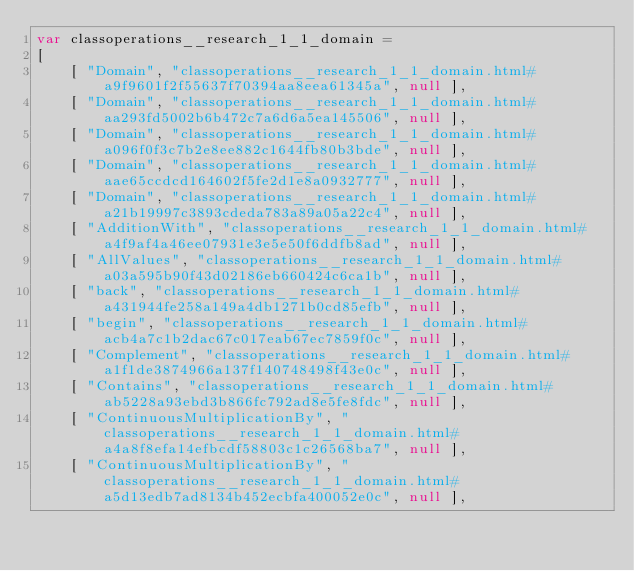<code> <loc_0><loc_0><loc_500><loc_500><_JavaScript_>var classoperations__research_1_1_domain =
[
    [ "Domain", "classoperations__research_1_1_domain.html#a9f9601f2f55637f70394aa8eea61345a", null ],
    [ "Domain", "classoperations__research_1_1_domain.html#aa293fd5002b6b472c7a6d6a5ea145506", null ],
    [ "Domain", "classoperations__research_1_1_domain.html#a096f0f3c7b2e8ee882c1644fb80b3bde", null ],
    [ "Domain", "classoperations__research_1_1_domain.html#aae65ccdcd164602f5fe2d1e8a0932777", null ],
    [ "Domain", "classoperations__research_1_1_domain.html#a21b19997c3893cdeda783a89a05a22c4", null ],
    [ "AdditionWith", "classoperations__research_1_1_domain.html#a4f9af4a46ee07931e3e5e50f6ddfb8ad", null ],
    [ "AllValues", "classoperations__research_1_1_domain.html#a03a595b90f43d02186eb660424c6ca1b", null ],
    [ "back", "classoperations__research_1_1_domain.html#a431944fe258a149a4db1271b0cd85efb", null ],
    [ "begin", "classoperations__research_1_1_domain.html#acb4a7c1b2dac67c017eab67ec7859f0c", null ],
    [ "Complement", "classoperations__research_1_1_domain.html#a1f1de3874966a137f140748498f43e0c", null ],
    [ "Contains", "classoperations__research_1_1_domain.html#ab5228a93ebd3b866fc792ad8e5fe8fdc", null ],
    [ "ContinuousMultiplicationBy", "classoperations__research_1_1_domain.html#a4a8f8efa14efbcdf58803c1c26568ba7", null ],
    [ "ContinuousMultiplicationBy", "classoperations__research_1_1_domain.html#a5d13edb7ad8134b452ecbfa400052e0c", null ],</code> 